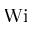Convert formula to latex. <formula><loc_0><loc_0><loc_500><loc_500>W i</formula> 